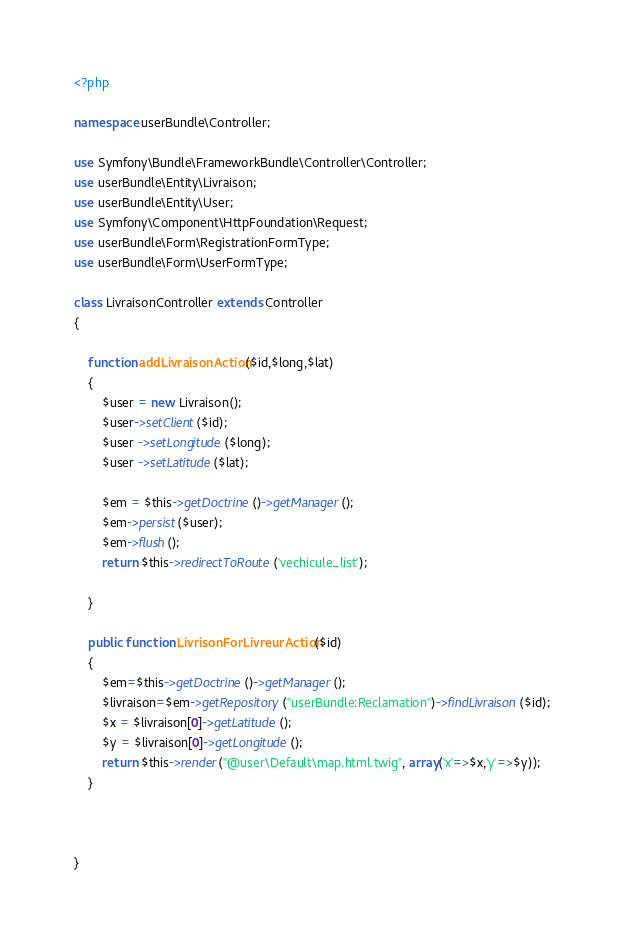<code> <loc_0><loc_0><loc_500><loc_500><_PHP_><?php

namespace userBundle\Controller;

use Symfony\Bundle\FrameworkBundle\Controller\Controller;
use userBundle\Entity\Livraison;
use userBundle\Entity\User;
use Symfony\Component\HttpFoundation\Request;
use userBundle\Form\RegistrationFormType;
use userBundle\Form\UserFormType;

class LivraisonController extends Controller
{

    function addLivraisonAction($id,$long,$lat)
    {
        $user = new Livraison();
        $user->setClient($id);
        $user ->setLongitude($long);
        $user ->setLatitude($lat);

        $em = $this->getDoctrine()->getManager();
        $em->persist($user);
        $em->flush();
        return $this->redirectToRoute('vechicule_list');

    }

    public function LivrisonForLivreurAction($id)
    {
        $em=$this->getDoctrine()->getManager();
        $livraison=$em->getRepository("userBundle:Reclamation")->findLivraison($id);
        $x = $livraison[0]->getLatitude();
        $y = $livraison[0]->getLongitude();
        return $this->render("@user\Default\map.html.twig", array('x'=>$x,'y'=>$y));
    }



}
</code> 